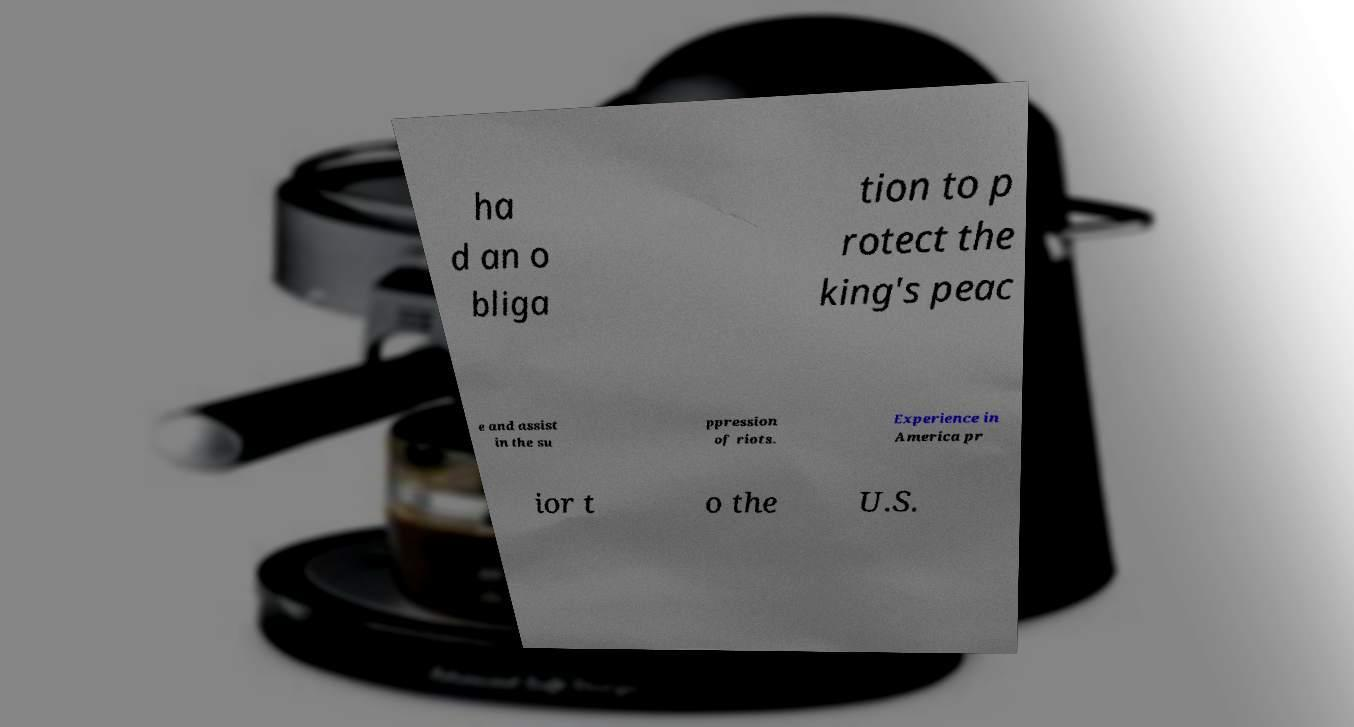Can you accurately transcribe the text from the provided image for me? ha d an o bliga tion to p rotect the king's peac e and assist in the su ppression of riots. Experience in America pr ior t o the U.S. 